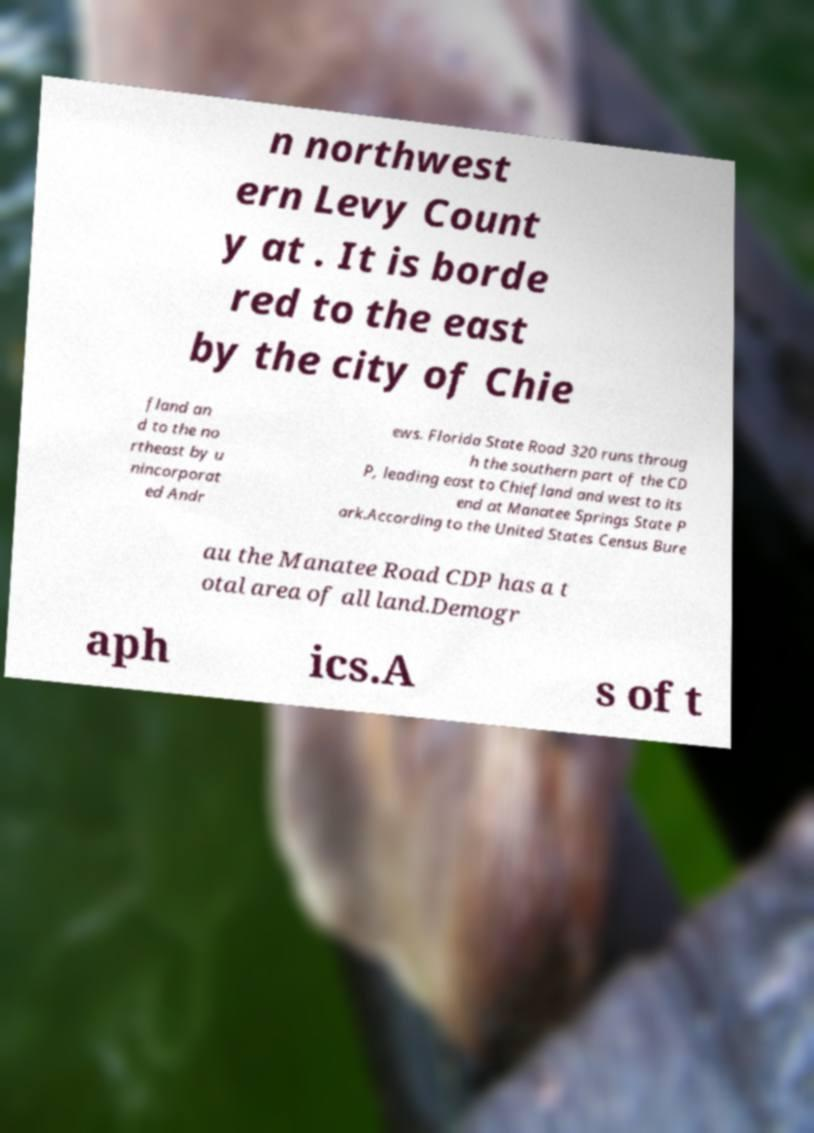Please read and relay the text visible in this image. What does it say? n northwest ern Levy Count y at . It is borde red to the east by the city of Chie fland an d to the no rtheast by u nincorporat ed Andr ews. Florida State Road 320 runs throug h the southern part of the CD P, leading east to Chiefland and west to its end at Manatee Springs State P ark.According to the United States Census Bure au the Manatee Road CDP has a t otal area of all land.Demogr aph ics.A s of t 